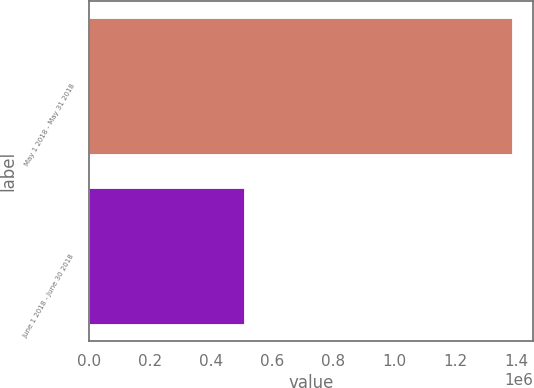Convert chart. <chart><loc_0><loc_0><loc_500><loc_500><bar_chart><fcel>May 1 2018 - May 31 2018<fcel>June 1 2018 - June 30 2018<nl><fcel>1.38719e+06<fcel>509269<nl></chart> 